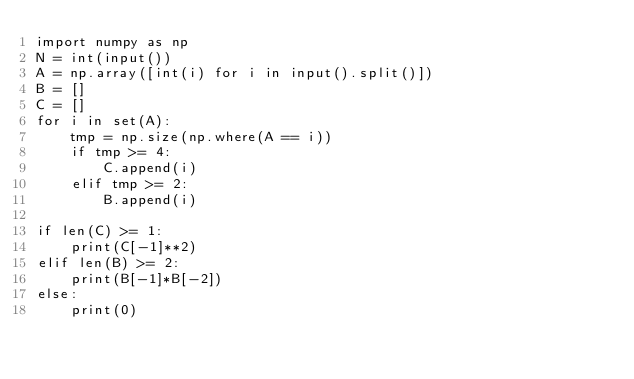Convert code to text. <code><loc_0><loc_0><loc_500><loc_500><_Python_>import numpy as np
N = int(input())
A = np.array([int(i) for i in input().split()])
B = []
C = []
for i in set(A):
    tmp = np.size(np.where(A == i))
    if tmp >= 4:
        C.append(i)
    elif tmp >= 2:
        B.append(i)

if len(C) >= 1:
    print(C[-1]**2)
elif len(B) >= 2:
    print(B[-1]*B[-2])
else:
    print(0)
</code> 